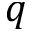Convert formula to latex. <formula><loc_0><loc_0><loc_500><loc_500>q</formula> 